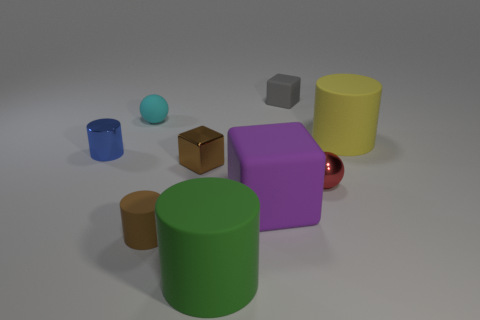Add 1 green blocks. How many objects exist? 10 Subtract all balls. How many objects are left? 7 Subtract 0 green cubes. How many objects are left? 9 Subtract all brown spheres. Subtract all metallic spheres. How many objects are left? 8 Add 8 small cyan rubber things. How many small cyan rubber things are left? 9 Add 6 small purple spheres. How many small purple spheres exist? 6 